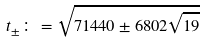Convert formula to latex. <formula><loc_0><loc_0><loc_500><loc_500>t _ { \pm } \colon = \sqrt { 7 1 4 4 0 \pm 6 8 0 2 \sqrt { 1 9 } }</formula> 